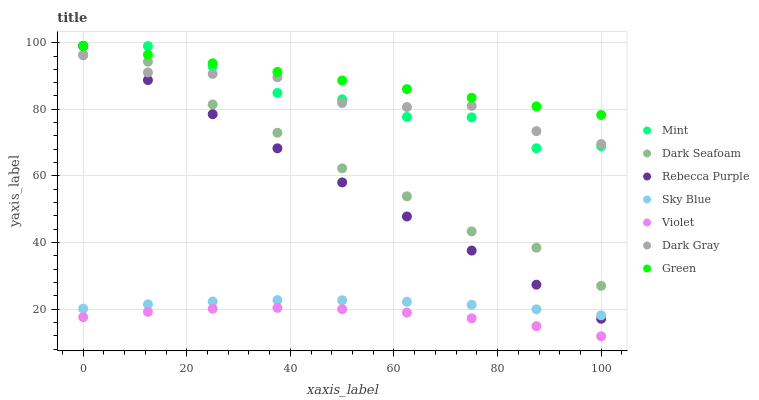Does Violet have the minimum area under the curve?
Answer yes or no. Yes. Does Green have the maximum area under the curve?
Answer yes or no. Yes. Does Dark Seafoam have the minimum area under the curve?
Answer yes or no. No. Does Dark Seafoam have the maximum area under the curve?
Answer yes or no. No. Is Rebecca Purple the smoothest?
Answer yes or no. Yes. Is Mint the roughest?
Answer yes or no. Yes. Is Dark Seafoam the smoothest?
Answer yes or no. No. Is Dark Seafoam the roughest?
Answer yes or no. No. Does Violet have the lowest value?
Answer yes or no. Yes. Does Dark Seafoam have the lowest value?
Answer yes or no. No. Does Mint have the highest value?
Answer yes or no. Yes. Does Dark Seafoam have the highest value?
Answer yes or no. No. Is Violet less than Green?
Answer yes or no. Yes. Is Mint greater than Dark Seafoam?
Answer yes or no. Yes. Does Dark Seafoam intersect Dark Gray?
Answer yes or no. Yes. Is Dark Seafoam less than Dark Gray?
Answer yes or no. No. Is Dark Seafoam greater than Dark Gray?
Answer yes or no. No. Does Violet intersect Green?
Answer yes or no. No. 